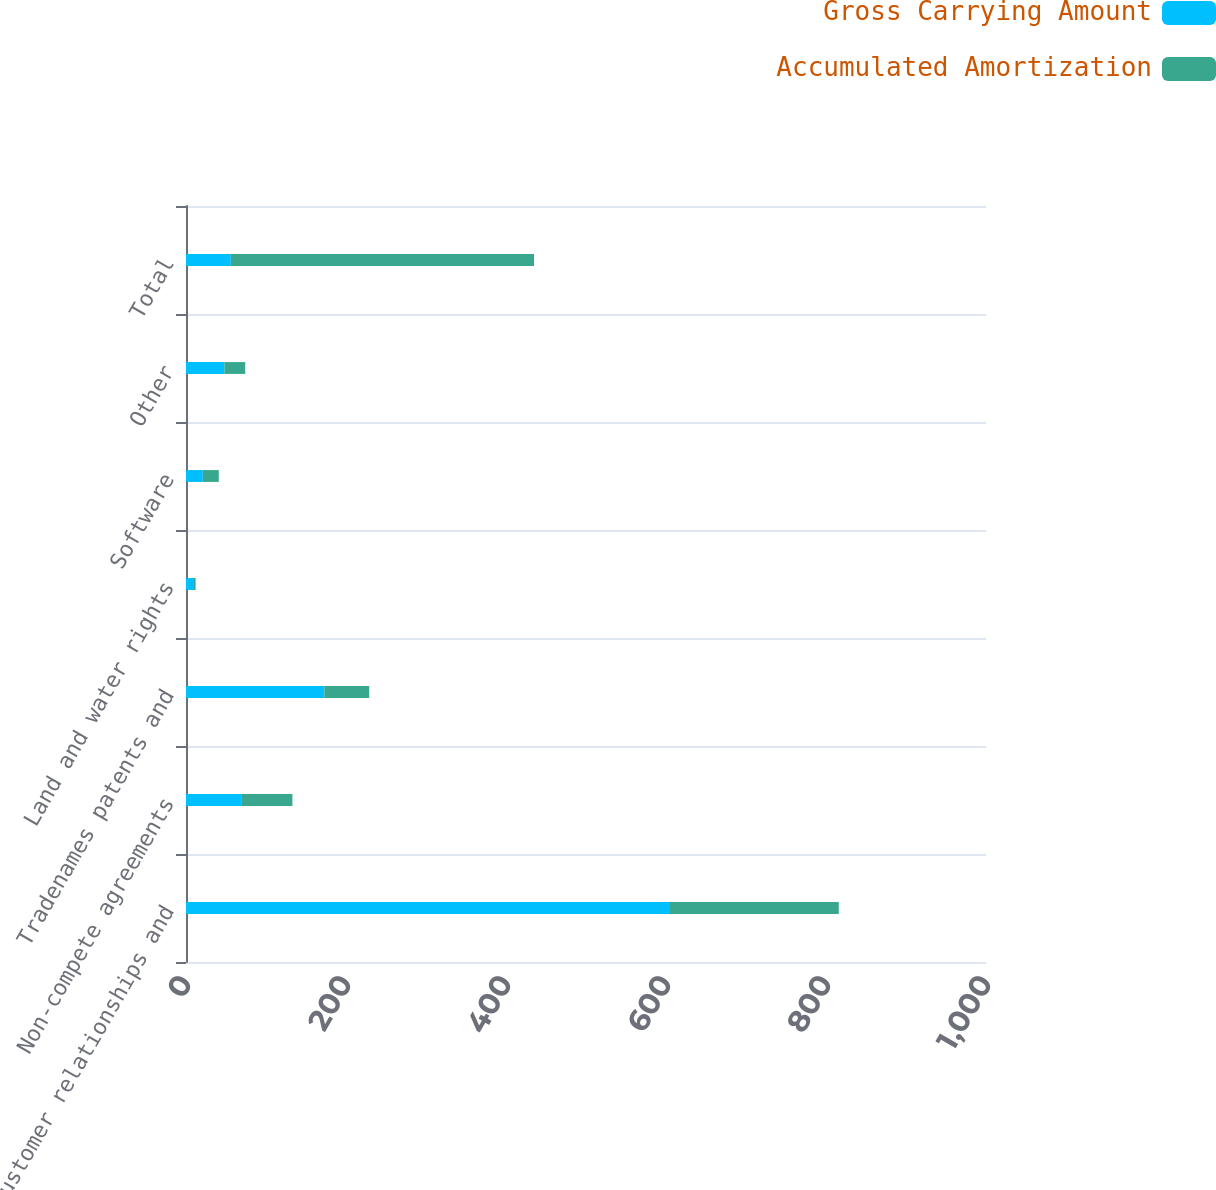Convert chart. <chart><loc_0><loc_0><loc_500><loc_500><stacked_bar_chart><ecel><fcel>Customer relationships and<fcel>Non-compete agreements<fcel>Tradenames patents and<fcel>Land and water rights<fcel>Software<fcel>Other<fcel>Total<nl><fcel>Gross Carrying Amount<fcel>605<fcel>69<fcel>173<fcel>10<fcel>21<fcel>48<fcel>56<nl><fcel>Accumulated Amortization<fcel>211<fcel>64<fcel>56<fcel>2<fcel>20<fcel>26<fcel>379<nl></chart> 